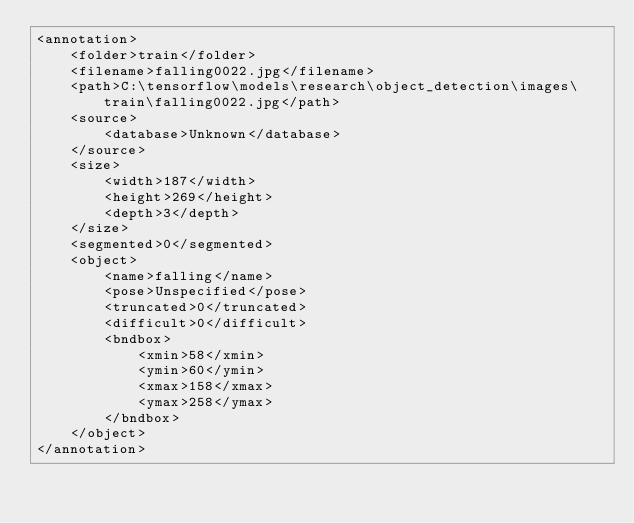<code> <loc_0><loc_0><loc_500><loc_500><_XML_><annotation>
	<folder>train</folder>
	<filename>falling0022.jpg</filename>
	<path>C:\tensorflow\models\research\object_detection\images\train\falling0022.jpg</path>
	<source>
		<database>Unknown</database>
	</source>
	<size>
		<width>187</width>
		<height>269</height>
		<depth>3</depth>
	</size>
	<segmented>0</segmented>
	<object>
		<name>falling</name>
		<pose>Unspecified</pose>
		<truncated>0</truncated>
		<difficult>0</difficult>
		<bndbox>
			<xmin>58</xmin>
			<ymin>60</ymin>
			<xmax>158</xmax>
			<ymax>258</ymax>
		</bndbox>
	</object>
</annotation>
</code> 